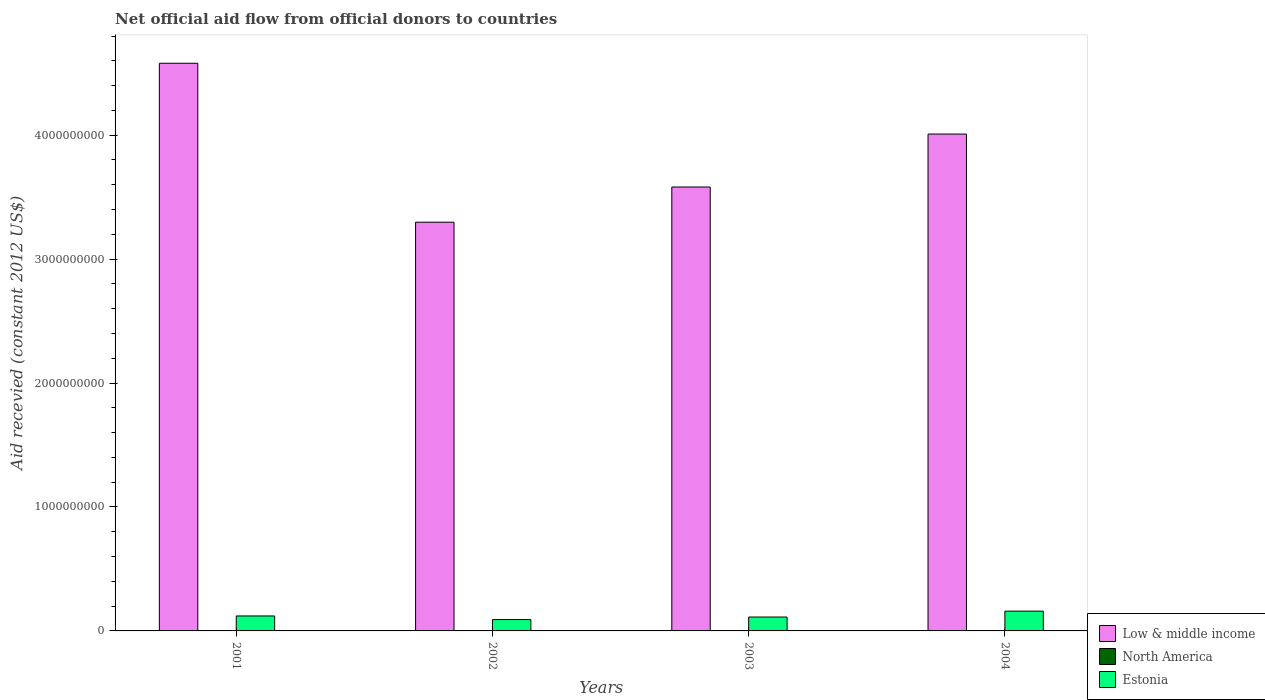How many different coloured bars are there?
Offer a very short reply. 3. How many groups of bars are there?
Offer a terse response. 4. Are the number of bars per tick equal to the number of legend labels?
Make the answer very short. Yes. Are the number of bars on each tick of the X-axis equal?
Provide a succinct answer. Yes. How many bars are there on the 2nd tick from the left?
Ensure brevity in your answer.  3. How many bars are there on the 3rd tick from the right?
Your response must be concise. 3. What is the label of the 3rd group of bars from the left?
Offer a terse response. 2003. What is the total aid received in North America in 2004?
Make the answer very short. 1.10e+05. Across all years, what is the maximum total aid received in Low & middle income?
Make the answer very short. 4.58e+09. Across all years, what is the minimum total aid received in Estonia?
Your response must be concise. 9.16e+07. In which year was the total aid received in North America minimum?
Give a very brief answer. 2002. What is the total total aid received in Estonia in the graph?
Keep it short and to the point. 4.84e+08. What is the difference between the total aid received in Estonia in 2001 and that in 2003?
Offer a terse response. 8.66e+06. What is the difference between the total aid received in North America in 2003 and the total aid received in Low & middle income in 2004?
Keep it short and to the point. -4.01e+09. What is the average total aid received in North America per year?
Offer a terse response. 5.50e+04. In the year 2001, what is the difference between the total aid received in Estonia and total aid received in Low & middle income?
Give a very brief answer. -4.46e+09. In how many years, is the total aid received in Low & middle income greater than 2000000000 US$?
Your response must be concise. 4. What is the ratio of the total aid received in Low & middle income in 2001 to that in 2002?
Keep it short and to the point. 1.39. Is the difference between the total aid received in Estonia in 2001 and 2003 greater than the difference between the total aid received in Low & middle income in 2001 and 2003?
Your answer should be very brief. No. What is the difference between the highest and the second highest total aid received in North America?
Your answer should be very brief. 7.00e+04. What is the difference between the highest and the lowest total aid received in Estonia?
Provide a short and direct response. 6.79e+07. What does the 1st bar from the right in 2004 represents?
Ensure brevity in your answer.  Estonia. Is it the case that in every year, the sum of the total aid received in North America and total aid received in Low & middle income is greater than the total aid received in Estonia?
Your answer should be very brief. Yes. How many bars are there?
Your answer should be very brief. 12. Are all the bars in the graph horizontal?
Offer a terse response. No. How many years are there in the graph?
Provide a succinct answer. 4. Does the graph contain grids?
Give a very brief answer. No. Where does the legend appear in the graph?
Make the answer very short. Bottom right. How many legend labels are there?
Give a very brief answer. 3. How are the legend labels stacked?
Ensure brevity in your answer.  Vertical. What is the title of the graph?
Provide a succinct answer. Net official aid flow from official donors to countries. What is the label or title of the X-axis?
Make the answer very short. Years. What is the label or title of the Y-axis?
Your answer should be very brief. Aid recevied (constant 2012 US$). What is the Aid recevied (constant 2012 US$) in Low & middle income in 2001?
Provide a succinct answer. 4.58e+09. What is the Aid recevied (constant 2012 US$) in North America in 2001?
Your answer should be compact. 4.00e+04. What is the Aid recevied (constant 2012 US$) of Estonia in 2001?
Your response must be concise. 1.21e+08. What is the Aid recevied (constant 2012 US$) in Low & middle income in 2002?
Ensure brevity in your answer.  3.30e+09. What is the Aid recevied (constant 2012 US$) in North America in 2002?
Your response must be concise. 3.00e+04. What is the Aid recevied (constant 2012 US$) in Estonia in 2002?
Keep it short and to the point. 9.16e+07. What is the Aid recevied (constant 2012 US$) in Low & middle income in 2003?
Your answer should be compact. 3.58e+09. What is the Aid recevied (constant 2012 US$) in North America in 2003?
Provide a short and direct response. 4.00e+04. What is the Aid recevied (constant 2012 US$) of Estonia in 2003?
Provide a short and direct response. 1.12e+08. What is the Aid recevied (constant 2012 US$) in Low & middle income in 2004?
Offer a very short reply. 4.01e+09. What is the Aid recevied (constant 2012 US$) in Estonia in 2004?
Provide a succinct answer. 1.59e+08. Across all years, what is the maximum Aid recevied (constant 2012 US$) of Low & middle income?
Keep it short and to the point. 4.58e+09. Across all years, what is the maximum Aid recevied (constant 2012 US$) in Estonia?
Keep it short and to the point. 1.59e+08. Across all years, what is the minimum Aid recevied (constant 2012 US$) in Low & middle income?
Make the answer very short. 3.30e+09. Across all years, what is the minimum Aid recevied (constant 2012 US$) of North America?
Ensure brevity in your answer.  3.00e+04. Across all years, what is the minimum Aid recevied (constant 2012 US$) of Estonia?
Give a very brief answer. 9.16e+07. What is the total Aid recevied (constant 2012 US$) in Low & middle income in the graph?
Your answer should be compact. 1.55e+1. What is the total Aid recevied (constant 2012 US$) of Estonia in the graph?
Your answer should be compact. 4.84e+08. What is the difference between the Aid recevied (constant 2012 US$) in Low & middle income in 2001 and that in 2002?
Your answer should be very brief. 1.28e+09. What is the difference between the Aid recevied (constant 2012 US$) of Estonia in 2001 and that in 2002?
Offer a terse response. 2.91e+07. What is the difference between the Aid recevied (constant 2012 US$) of Low & middle income in 2001 and that in 2003?
Ensure brevity in your answer.  9.98e+08. What is the difference between the Aid recevied (constant 2012 US$) of North America in 2001 and that in 2003?
Your answer should be very brief. 0. What is the difference between the Aid recevied (constant 2012 US$) of Estonia in 2001 and that in 2003?
Provide a short and direct response. 8.66e+06. What is the difference between the Aid recevied (constant 2012 US$) of Low & middle income in 2001 and that in 2004?
Your response must be concise. 5.71e+08. What is the difference between the Aid recevied (constant 2012 US$) of Estonia in 2001 and that in 2004?
Keep it short and to the point. -3.88e+07. What is the difference between the Aid recevied (constant 2012 US$) in Low & middle income in 2002 and that in 2003?
Your answer should be very brief. -2.84e+08. What is the difference between the Aid recevied (constant 2012 US$) in North America in 2002 and that in 2003?
Ensure brevity in your answer.  -10000. What is the difference between the Aid recevied (constant 2012 US$) in Estonia in 2002 and that in 2003?
Provide a short and direct response. -2.05e+07. What is the difference between the Aid recevied (constant 2012 US$) in Low & middle income in 2002 and that in 2004?
Provide a short and direct response. -7.11e+08. What is the difference between the Aid recevied (constant 2012 US$) in North America in 2002 and that in 2004?
Make the answer very short. -8.00e+04. What is the difference between the Aid recevied (constant 2012 US$) in Estonia in 2002 and that in 2004?
Ensure brevity in your answer.  -6.79e+07. What is the difference between the Aid recevied (constant 2012 US$) in Low & middle income in 2003 and that in 2004?
Your answer should be very brief. -4.27e+08. What is the difference between the Aid recevied (constant 2012 US$) of Estonia in 2003 and that in 2004?
Provide a succinct answer. -4.74e+07. What is the difference between the Aid recevied (constant 2012 US$) in Low & middle income in 2001 and the Aid recevied (constant 2012 US$) in North America in 2002?
Your answer should be very brief. 4.58e+09. What is the difference between the Aid recevied (constant 2012 US$) of Low & middle income in 2001 and the Aid recevied (constant 2012 US$) of Estonia in 2002?
Give a very brief answer. 4.49e+09. What is the difference between the Aid recevied (constant 2012 US$) in North America in 2001 and the Aid recevied (constant 2012 US$) in Estonia in 2002?
Provide a short and direct response. -9.16e+07. What is the difference between the Aid recevied (constant 2012 US$) of Low & middle income in 2001 and the Aid recevied (constant 2012 US$) of North America in 2003?
Keep it short and to the point. 4.58e+09. What is the difference between the Aid recevied (constant 2012 US$) in Low & middle income in 2001 and the Aid recevied (constant 2012 US$) in Estonia in 2003?
Give a very brief answer. 4.47e+09. What is the difference between the Aid recevied (constant 2012 US$) in North America in 2001 and the Aid recevied (constant 2012 US$) in Estonia in 2003?
Offer a very short reply. -1.12e+08. What is the difference between the Aid recevied (constant 2012 US$) of Low & middle income in 2001 and the Aid recevied (constant 2012 US$) of North America in 2004?
Keep it short and to the point. 4.58e+09. What is the difference between the Aid recevied (constant 2012 US$) in Low & middle income in 2001 and the Aid recevied (constant 2012 US$) in Estonia in 2004?
Give a very brief answer. 4.42e+09. What is the difference between the Aid recevied (constant 2012 US$) in North America in 2001 and the Aid recevied (constant 2012 US$) in Estonia in 2004?
Your answer should be compact. -1.59e+08. What is the difference between the Aid recevied (constant 2012 US$) of Low & middle income in 2002 and the Aid recevied (constant 2012 US$) of North America in 2003?
Make the answer very short. 3.30e+09. What is the difference between the Aid recevied (constant 2012 US$) of Low & middle income in 2002 and the Aid recevied (constant 2012 US$) of Estonia in 2003?
Provide a succinct answer. 3.19e+09. What is the difference between the Aid recevied (constant 2012 US$) in North America in 2002 and the Aid recevied (constant 2012 US$) in Estonia in 2003?
Your response must be concise. -1.12e+08. What is the difference between the Aid recevied (constant 2012 US$) in Low & middle income in 2002 and the Aid recevied (constant 2012 US$) in North America in 2004?
Ensure brevity in your answer.  3.30e+09. What is the difference between the Aid recevied (constant 2012 US$) of Low & middle income in 2002 and the Aid recevied (constant 2012 US$) of Estonia in 2004?
Your response must be concise. 3.14e+09. What is the difference between the Aid recevied (constant 2012 US$) of North America in 2002 and the Aid recevied (constant 2012 US$) of Estonia in 2004?
Give a very brief answer. -1.59e+08. What is the difference between the Aid recevied (constant 2012 US$) of Low & middle income in 2003 and the Aid recevied (constant 2012 US$) of North America in 2004?
Make the answer very short. 3.58e+09. What is the difference between the Aid recevied (constant 2012 US$) in Low & middle income in 2003 and the Aid recevied (constant 2012 US$) in Estonia in 2004?
Ensure brevity in your answer.  3.42e+09. What is the difference between the Aid recevied (constant 2012 US$) in North America in 2003 and the Aid recevied (constant 2012 US$) in Estonia in 2004?
Your answer should be very brief. -1.59e+08. What is the average Aid recevied (constant 2012 US$) of Low & middle income per year?
Make the answer very short. 3.87e+09. What is the average Aid recevied (constant 2012 US$) of North America per year?
Provide a succinct answer. 5.50e+04. What is the average Aid recevied (constant 2012 US$) of Estonia per year?
Give a very brief answer. 1.21e+08. In the year 2001, what is the difference between the Aid recevied (constant 2012 US$) in Low & middle income and Aid recevied (constant 2012 US$) in North America?
Your answer should be very brief. 4.58e+09. In the year 2001, what is the difference between the Aid recevied (constant 2012 US$) of Low & middle income and Aid recevied (constant 2012 US$) of Estonia?
Provide a succinct answer. 4.46e+09. In the year 2001, what is the difference between the Aid recevied (constant 2012 US$) in North America and Aid recevied (constant 2012 US$) in Estonia?
Provide a short and direct response. -1.21e+08. In the year 2002, what is the difference between the Aid recevied (constant 2012 US$) of Low & middle income and Aid recevied (constant 2012 US$) of North America?
Ensure brevity in your answer.  3.30e+09. In the year 2002, what is the difference between the Aid recevied (constant 2012 US$) of Low & middle income and Aid recevied (constant 2012 US$) of Estonia?
Offer a terse response. 3.21e+09. In the year 2002, what is the difference between the Aid recevied (constant 2012 US$) of North America and Aid recevied (constant 2012 US$) of Estonia?
Offer a very short reply. -9.16e+07. In the year 2003, what is the difference between the Aid recevied (constant 2012 US$) in Low & middle income and Aid recevied (constant 2012 US$) in North America?
Your response must be concise. 3.58e+09. In the year 2003, what is the difference between the Aid recevied (constant 2012 US$) in Low & middle income and Aid recevied (constant 2012 US$) in Estonia?
Your response must be concise. 3.47e+09. In the year 2003, what is the difference between the Aid recevied (constant 2012 US$) of North America and Aid recevied (constant 2012 US$) of Estonia?
Your answer should be very brief. -1.12e+08. In the year 2004, what is the difference between the Aid recevied (constant 2012 US$) of Low & middle income and Aid recevied (constant 2012 US$) of North America?
Provide a succinct answer. 4.01e+09. In the year 2004, what is the difference between the Aid recevied (constant 2012 US$) in Low & middle income and Aid recevied (constant 2012 US$) in Estonia?
Provide a succinct answer. 3.85e+09. In the year 2004, what is the difference between the Aid recevied (constant 2012 US$) in North America and Aid recevied (constant 2012 US$) in Estonia?
Offer a very short reply. -1.59e+08. What is the ratio of the Aid recevied (constant 2012 US$) in Low & middle income in 2001 to that in 2002?
Ensure brevity in your answer.  1.39. What is the ratio of the Aid recevied (constant 2012 US$) of North America in 2001 to that in 2002?
Offer a terse response. 1.33. What is the ratio of the Aid recevied (constant 2012 US$) in Estonia in 2001 to that in 2002?
Give a very brief answer. 1.32. What is the ratio of the Aid recevied (constant 2012 US$) in Low & middle income in 2001 to that in 2003?
Your response must be concise. 1.28. What is the ratio of the Aid recevied (constant 2012 US$) in Estonia in 2001 to that in 2003?
Your answer should be compact. 1.08. What is the ratio of the Aid recevied (constant 2012 US$) in Low & middle income in 2001 to that in 2004?
Your response must be concise. 1.14. What is the ratio of the Aid recevied (constant 2012 US$) of North America in 2001 to that in 2004?
Make the answer very short. 0.36. What is the ratio of the Aid recevied (constant 2012 US$) in Estonia in 2001 to that in 2004?
Your answer should be very brief. 0.76. What is the ratio of the Aid recevied (constant 2012 US$) of Low & middle income in 2002 to that in 2003?
Provide a succinct answer. 0.92. What is the ratio of the Aid recevied (constant 2012 US$) in North America in 2002 to that in 2003?
Ensure brevity in your answer.  0.75. What is the ratio of the Aid recevied (constant 2012 US$) of Estonia in 2002 to that in 2003?
Provide a short and direct response. 0.82. What is the ratio of the Aid recevied (constant 2012 US$) in Low & middle income in 2002 to that in 2004?
Provide a succinct answer. 0.82. What is the ratio of the Aid recevied (constant 2012 US$) in North America in 2002 to that in 2004?
Your response must be concise. 0.27. What is the ratio of the Aid recevied (constant 2012 US$) in Estonia in 2002 to that in 2004?
Keep it short and to the point. 0.57. What is the ratio of the Aid recevied (constant 2012 US$) of Low & middle income in 2003 to that in 2004?
Your answer should be very brief. 0.89. What is the ratio of the Aid recevied (constant 2012 US$) of North America in 2003 to that in 2004?
Your answer should be very brief. 0.36. What is the ratio of the Aid recevied (constant 2012 US$) in Estonia in 2003 to that in 2004?
Ensure brevity in your answer.  0.7. What is the difference between the highest and the second highest Aid recevied (constant 2012 US$) of Low & middle income?
Provide a succinct answer. 5.71e+08. What is the difference between the highest and the second highest Aid recevied (constant 2012 US$) of Estonia?
Give a very brief answer. 3.88e+07. What is the difference between the highest and the lowest Aid recevied (constant 2012 US$) of Low & middle income?
Make the answer very short. 1.28e+09. What is the difference between the highest and the lowest Aid recevied (constant 2012 US$) of North America?
Offer a very short reply. 8.00e+04. What is the difference between the highest and the lowest Aid recevied (constant 2012 US$) in Estonia?
Ensure brevity in your answer.  6.79e+07. 